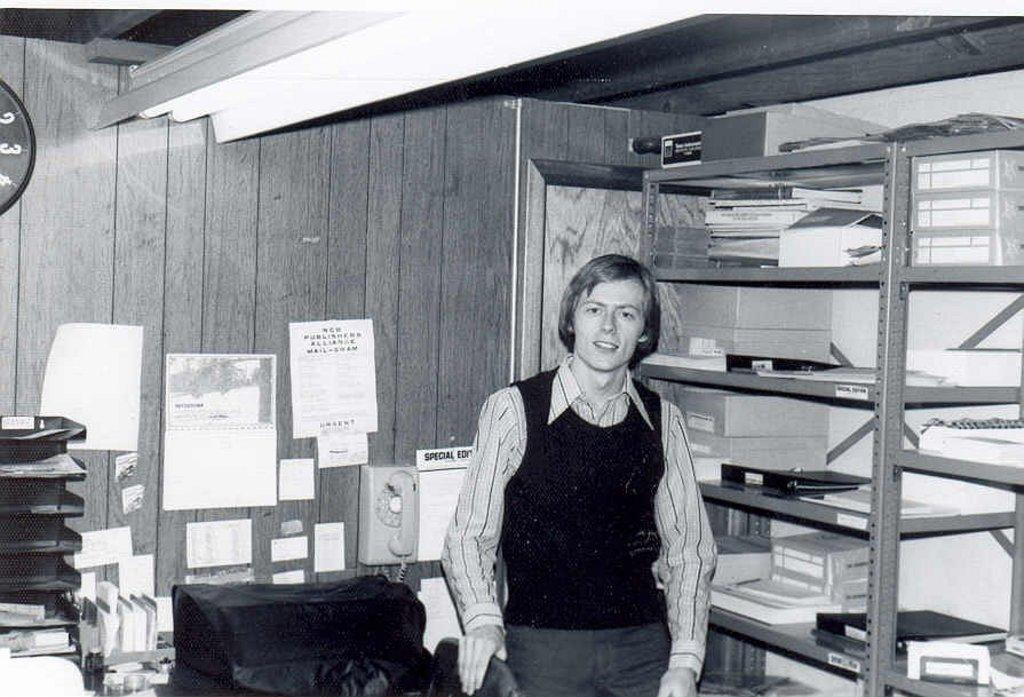What is the person in the image doing? The person is standing and holding a chair. What else can be seen in the image besides the person? There are books on a shelf and papers stuck on the wall. What is the background of the image? There is a wall visible in the image. What might the person be planning to do with the chair? The person might be planning to move or place the chair somewhere. What type of support can be seen rolling on the floor in the image? There is no support or rolling object present in the image. 